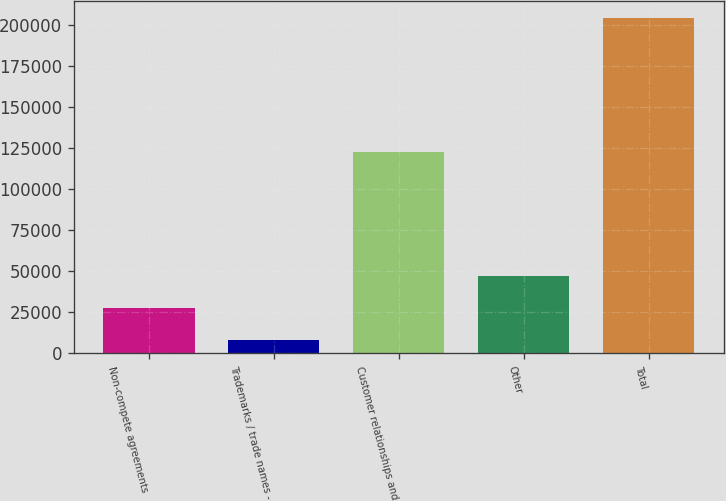<chart> <loc_0><loc_0><loc_500><loc_500><bar_chart><fcel>Non-compete agreements<fcel>Trademarks / trade names -<fcel>Customer relationships and<fcel>Other<fcel>Total<nl><fcel>27523.9<fcel>7866<fcel>122769<fcel>47181.8<fcel>204445<nl></chart> 